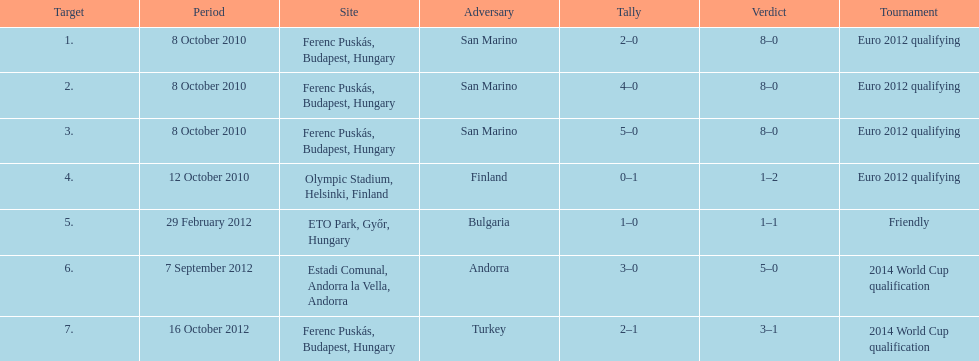In what year did ádám szalai make his next international goal after 2010? 2012. 